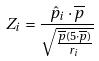Convert formula to latex. <formula><loc_0><loc_0><loc_500><loc_500>Z _ { i } = \frac { \hat { p } _ { i } \cdot \overline { p } } { \sqrt { \frac { \overline { p } ( 5 \cdot \overline { p } ) } { r _ { i } } } }</formula> 